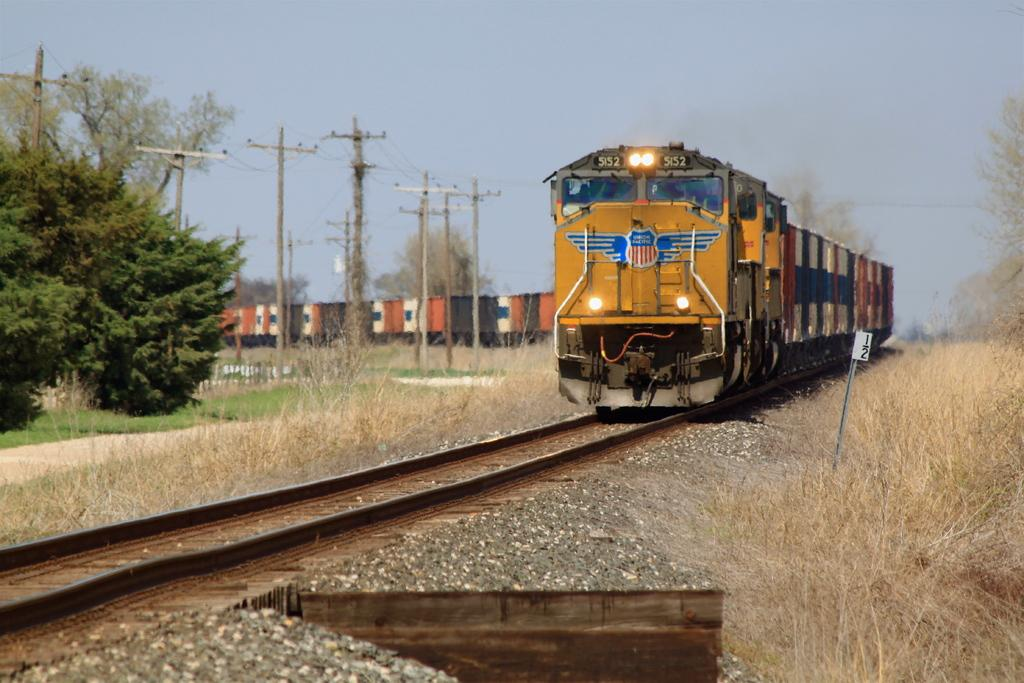What is the main subject of the image? There is a train in the image. Where is the train located? The train is on a railway track. What type of vegetation can be seen in the image? There are trees visible in the image. What else can be seen in the image besides the train and trees? There are poles in the image. What is visible in the background of the image? The sky is visible in the background of the image. Can you tell me how many bears are sitting on the train in the image? There are no bears present in the image; it features a train on a railway track with trees, poles, and a visible sky in the background. 